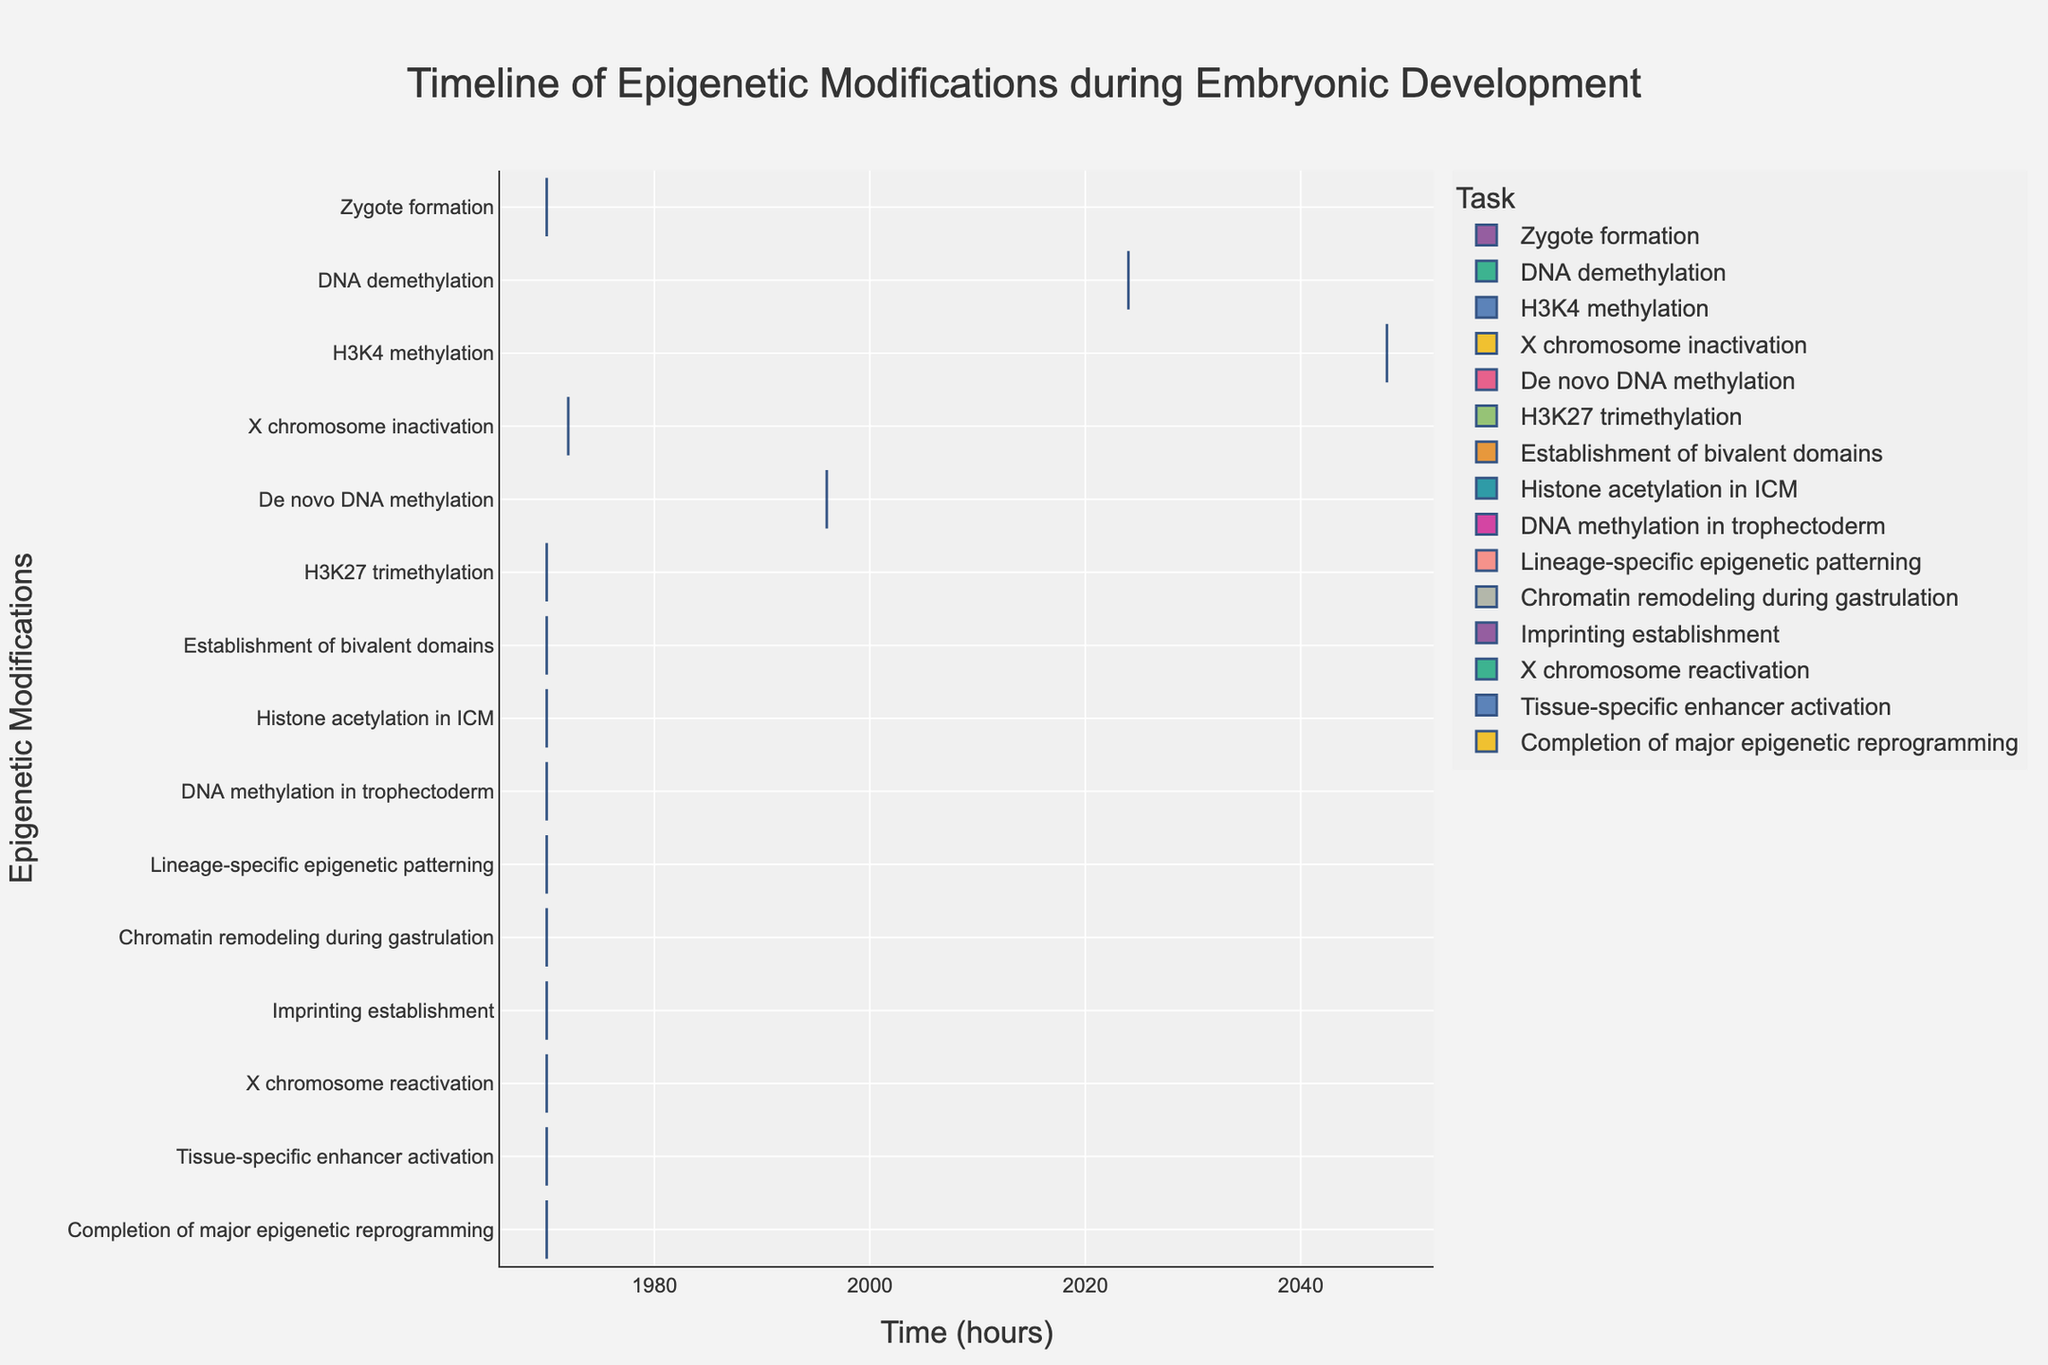What is the title of the Gantt chart? The title of the Gantt chart is displayed at the top of the figure.
Answer: Timeline of Epigenetic Modifications during Embryonic Development What are the minimum and maximum time values in the chart? The minimum and maximum time values can be found by looking at the x-axis for the start and end values. The start value is 0 hours, and the end value is 576 hours.
Answer: 0 hours, 576 hours Which epigenetic modification starts at 72 hours and how long does it last? X chromosome inactivation starts at 72 hours. By finding its end value at 144 hours, the duration is calculated by subtracting the start time from the end time: 144 - 72 = 72 hours.
Answer: X chromosome inactivation, 72 hours How many epigenetic modifications start at or after 200 hours? List the modifications along with their start times and count how many start at or after 200 hours. They are DNA methylation in trophectoderm (192), Lineage-specific epigenetic patterning (216), Chromatin remodeling during gastrulation (264), Imprinting establishment (288), X chromosome reactivation (312), Tissue-specific enhancer activation (360), and Completion of major epigenetic reprogramming (432). So, 5 modifications.
Answer: 5 Which two epigenetic modifications overlap in time between 144 and 192 hours? Check the tasks' start and end times. 'Establishment of bivalent domains' (144 to 240 hours) and 'De novo DNA methylation' (96 to 192 hours) overlap from 144 to 192 hours.
Answer: Establishment of bivalent domains, De novo DNA methylation What is the combined duration of DNA demethylation and H3K4 methylation? To find the combined duration, add the durations of each task. DNA demethylation (72 - 24) lasts 48 hours, and H3K4 methylation (120 - 48) lasts 72 hours. So, 48 + 72 = 120 hours.
Answer: 120 hours Which epigenetic modification lasts the longest, and what is its duration? By checking the duration of each task, 'Completion of major epigenetic reprogramming' is the longest (576 - 432), which is 144 hours.
Answer: Completion of major epigenetic reprogramming, 144 hours What is the task that begins immediately after 'Histone acetylation in ICM' ends? 'Histone acetylation in ICM' ends at 264 hours. The task that begins at 264 hours is 'Chromatin remodeling during gastrulation'.
Answer: Chromatin remodeling during gastrulation Which epigenetic modifications are scheduled to end before 300 hours? List modifications ending before 300 hours. They are 'Zygote formation' (24), 'DNA demethylation' (72), 'H3K4 methylation' (120), 'X chromosome inactivation' (144), 'De novo DNA methylation' (192), 'H3K27 trimethylation' (216), 'Establishment of bivalent domains' (240), 'Histone acetylation in ICM' (264), and 'DNA methylation in trophectoderm' (288). So, 9 modifications.
Answer: 9 